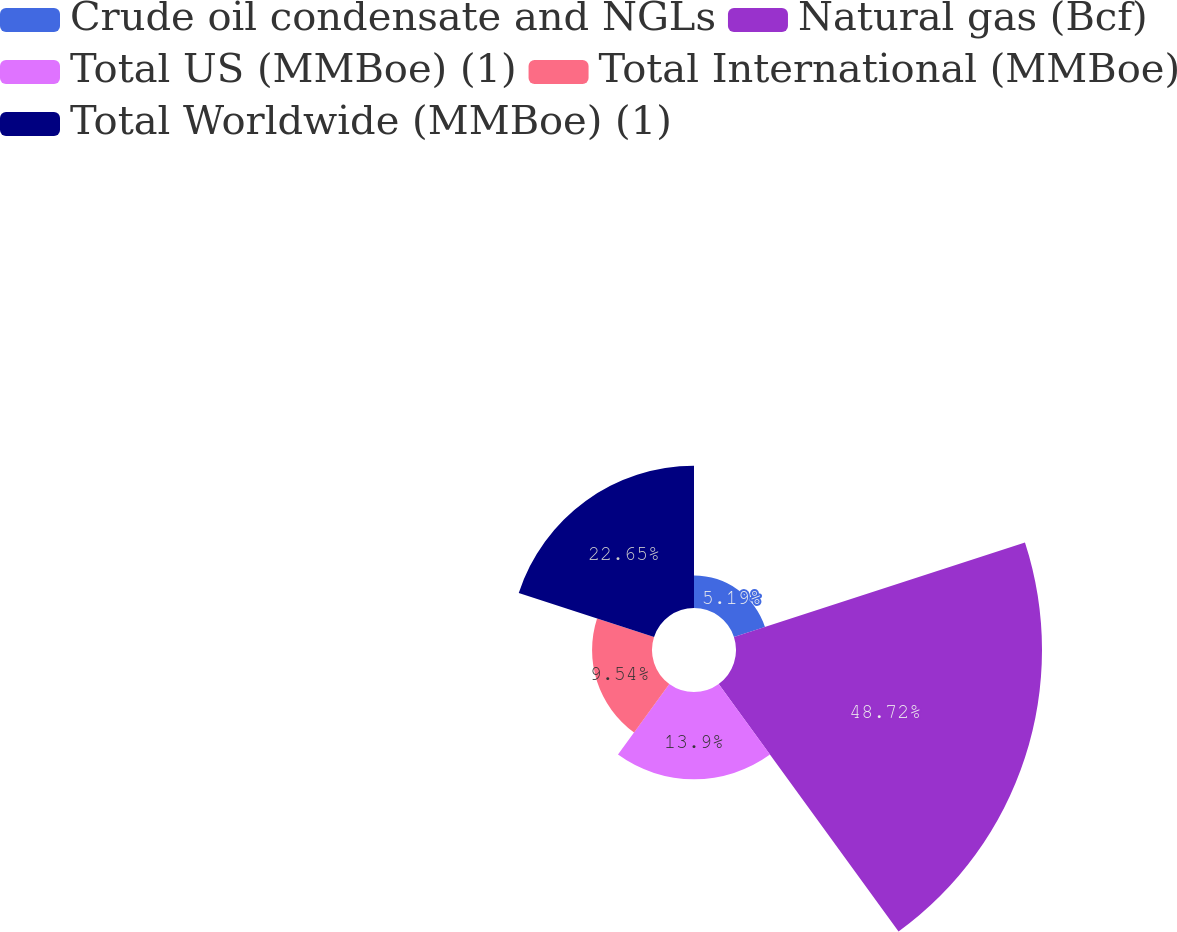<chart> <loc_0><loc_0><loc_500><loc_500><pie_chart><fcel>Crude oil condensate and NGLs<fcel>Natural gas (Bcf)<fcel>Total US (MMBoe) (1)<fcel>Total International (MMBoe)<fcel>Total Worldwide (MMBoe) (1)<nl><fcel>5.19%<fcel>48.72%<fcel>13.9%<fcel>9.54%<fcel>22.65%<nl></chart> 